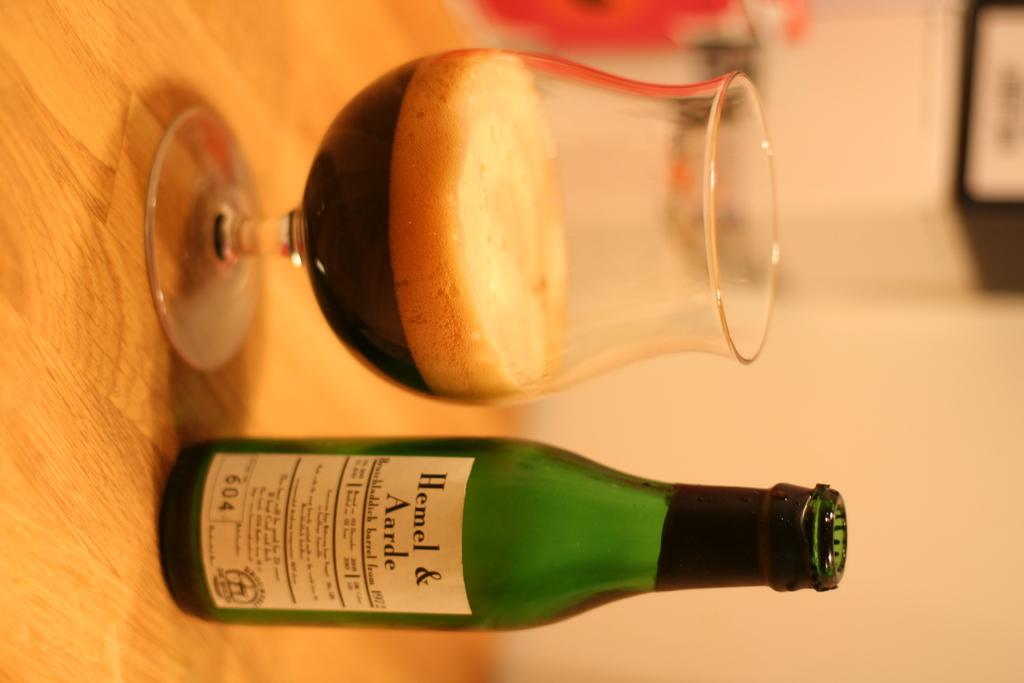<image>
Present a compact description of the photo's key features. a bottle that says Hemel on  the front 